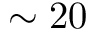Convert formula to latex. <formula><loc_0><loc_0><loc_500><loc_500>\sim 2 0</formula> 